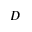Convert formula to latex. <formula><loc_0><loc_0><loc_500><loc_500>D</formula> 